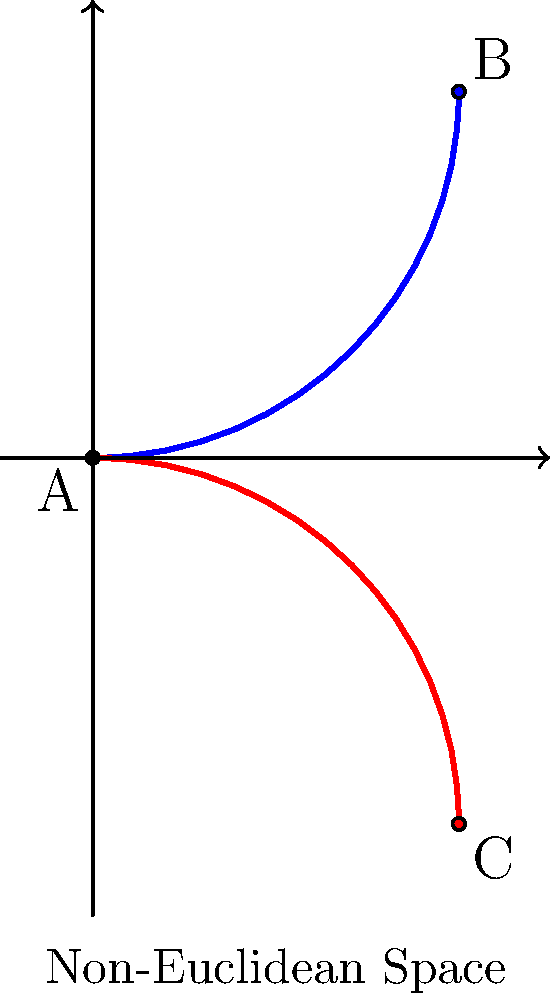In the context of non-Euclidean geometry, as depicted in the image, why do the light paths (represented by the blue and red curves) deviate from straight lines? How might this concept be utilized in a medical thriller to create a unique plot device? To understand this concept, let's break it down step-by-step:

1. In Euclidean geometry, light travels in straight lines. However, in non-Euclidean space, this is not always the case.

2. The image shows two curved paths (blue and red) representing light rays in non-Euclidean space.

3. These curves indicate that the space itself is curved or warped, causing light to follow geodesics (the shortest path between two points in curved space) rather than straight lines.

4. This phenomenon is similar to how light bends due to gravity in Einstein's theory of general relativity, where massive objects curve spacetime.

5. In non-Euclidean geometry, the curvature of space can be positive (like on a sphere) or negative (like on a saddle surface), affecting how light travels.

6. For a medical thriller, this concept could be used in various ways:
   a) A experimental drug that alters a patient's perception of space, causing them to see light paths as curved.
   b) A mysterious illness that affects the brain's processing of visual information, making the world appear non-Euclidean.
   c) A cutting-edge medical imaging technology that utilizes non-Euclidean geometry to visualize complex anatomical structures.

7. The plot could involve scientists or doctors trying to understand and solve problems related to these non-Euclidean phenomena, adding a unique twist to the medical thriller genre.
Answer: Curved spacetime causes light to follow geodesics instead of straight lines, providing potential for unique medical thriller plot devices. 